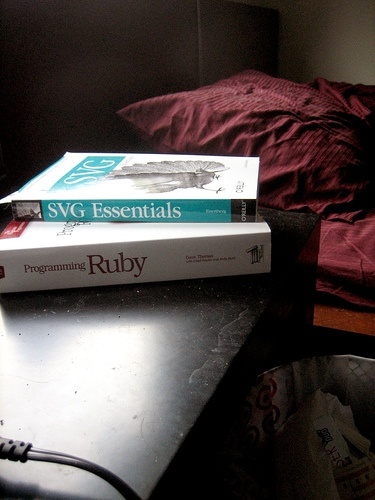Describe the objects in this image and their specific colors. I can see bed in black, maroon, and brown tones, book in black, gray, and white tones, and book in black, white, darkgray, and teal tones in this image. 